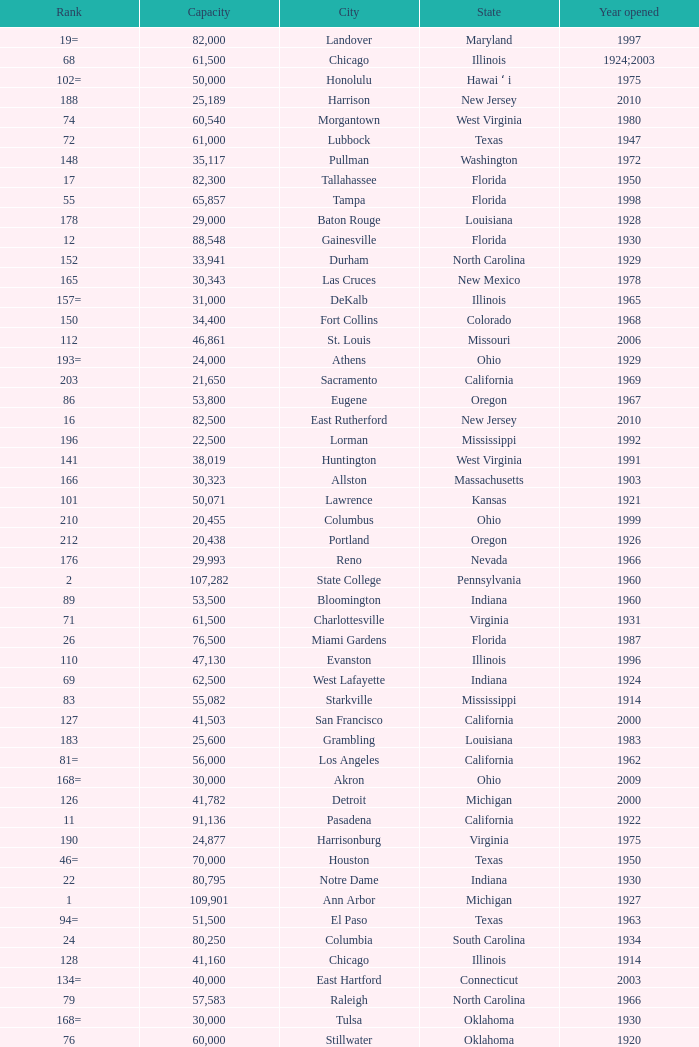What is the lowest capacity for 1903? 30323.0. 